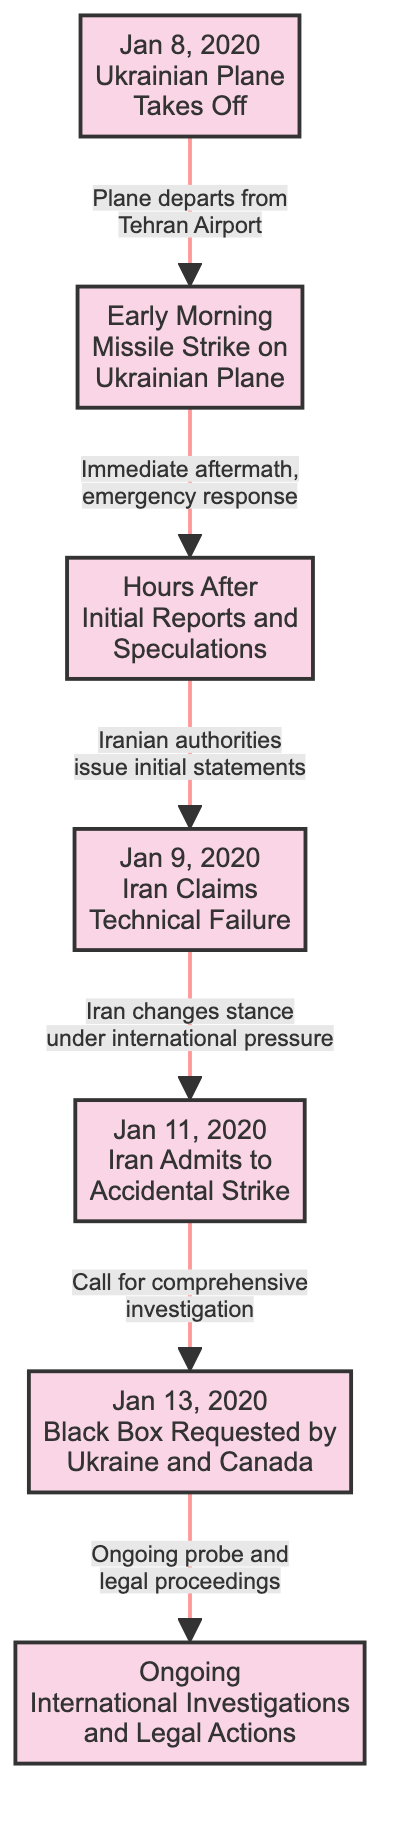What is the first event in the timeline? The diagram starts with the first event labeled "Jan 8, 2020<br>Ukrainian Plane<br>Takes Off", which identifies the initiation of the timeline.
Answer: Jan 8, 2020 What event follows the missile strike? The diagram indicates that after the missile strike on the Ukrainian plane, the next event is "Hours After<br>Initial Reports and<br>Speculations," marking the immediate aftermath.
Answer: Hours After Initial Reports and Speculations How many key events are represented in the diagram? The diagram contains a total of seven events from the initial plane departure to ongoing investigations, which can be counted directly from the event nodes.
Answer: 7 What did Iran claim on January 9, 2020? According to the diagram, on January 9, 2020, "Iran Claims<br>Technical Failure," representing Iran's initial position following the incident.
Answer: Technical Failure Which event leads to the call for a comprehensive investigation? The call for a comprehensive investigation comes after "Iran Admits to<br>Accidental Strike" on January 11, 2020, as indicated by the flow from event 5 to event 6.
Answer: Iran Admits to Accidental Strike What was the response to the initial reports by Iranian authorities? The diagram shows that the Iranian authorities' initial response is indicated as issuing statements after the hours of initial reports, reflected in the transition from event 2 to event 3.
Answer: Initial statements What is the relationship between the acknowledgment of an accidental strike and the request for the black box? After Iran's acknowledgment of the accidental strike, a request for the black box by Ukraine and Canada follows, as illustrated by the flow from event 5 to event 6, indicating a direct sequence of actions.
Answer: Request for the black box What continuous action is noted after the request for the black box? The ongoing international investigations and legal actions continue following the request for the black box, as shown in the connection from event 6 to event 7.
Answer: Ongoing International Investigations and Legal Actions What action is indicated at the end of the timeline? The final action noted in the timeline is "Ongoing<br>International Investigations<br>and Legal Actions," which depicts the sustained efforts following the incident.
Answer: Ongoing International Investigations and Legal Actions 